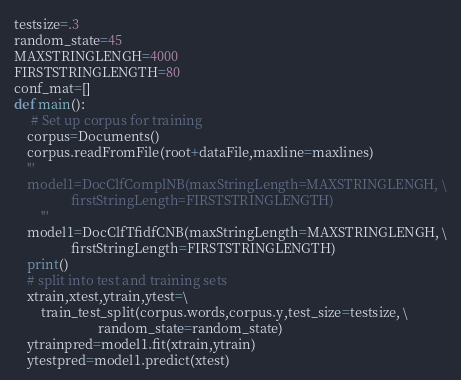<code> <loc_0><loc_0><loc_500><loc_500><_Python_>testsize=.3
random_state=45
MAXSTRINGLENGH=4000
FIRSTSTRINGLENGTH=80
conf_mat=[]
def main():  
     # Set up corpus for training               
    corpus=Documents()
    corpus.readFromFile(root+dataFile,maxline=maxlines)
    ''' 
    model1=DocClfComplNB(maxStringLength=MAXSTRINGLENGH, \
                 firstStringLength=FIRSTSTRINGLENGTH)
        '''
    model1=DocClfTfidfCNB(maxStringLength=MAXSTRINGLENGH, \
                 firstStringLength=FIRSTSTRINGLENGTH)
    print()
    # split into test and training sets
    xtrain,xtest,ytrain,ytest=\
        train_test_split(corpus.words,corpus.y,test_size=testsize, \
                         random_state=random_state)
    ytrainpred=model1.fit(xtrain,ytrain)
    ytestpred=model1.predict(xtest)
</code> 